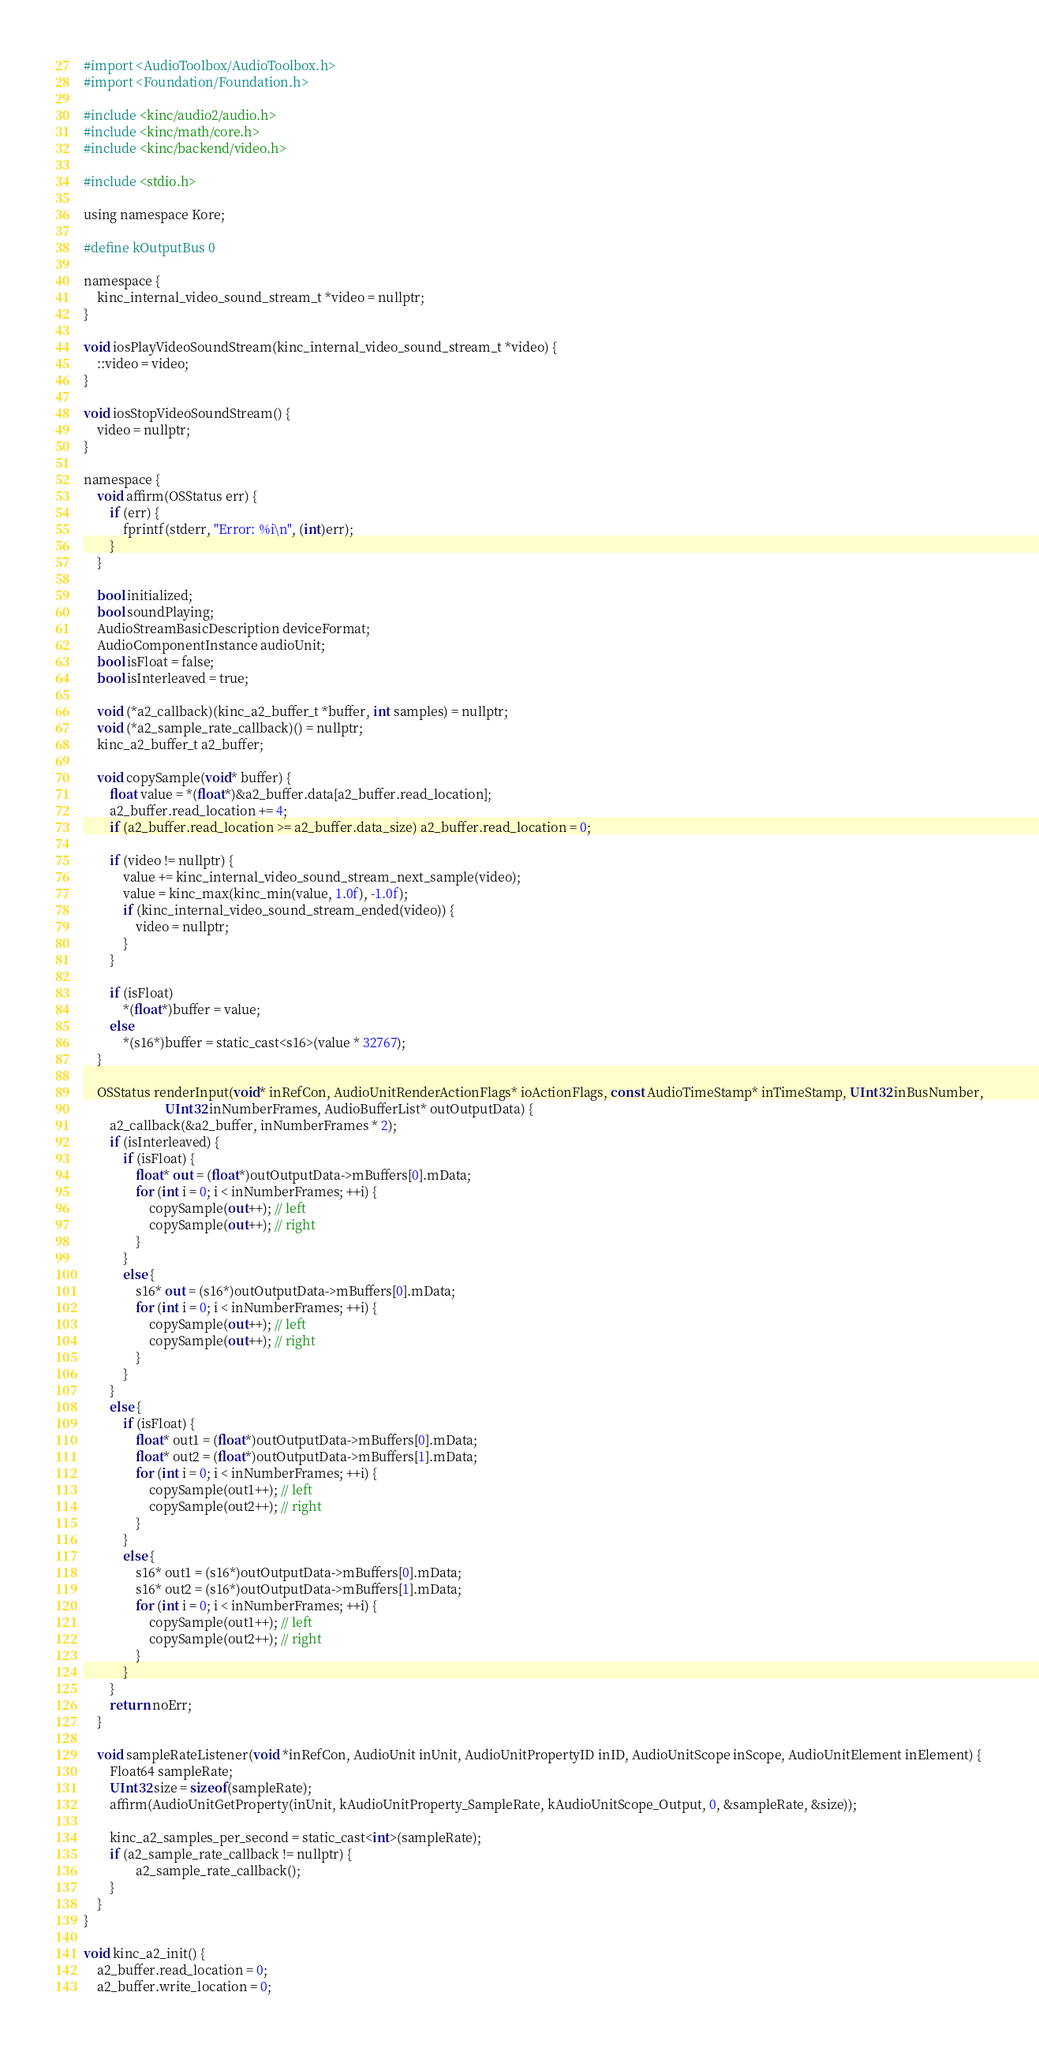Convert code to text. <code><loc_0><loc_0><loc_500><loc_500><_ObjectiveC_>#import <AudioToolbox/AudioToolbox.h>
#import <Foundation/Foundation.h>

#include <kinc/audio2/audio.h>
#include <kinc/math/core.h>
#include <kinc/backend/video.h>

#include <stdio.h>

using namespace Kore;

#define kOutputBus 0

namespace {
	kinc_internal_video_sound_stream_t *video = nullptr;
}

void iosPlayVideoSoundStream(kinc_internal_video_sound_stream_t *video) {
	::video = video;
}

void iosStopVideoSoundStream() {
	video = nullptr;
}

namespace {
	void affirm(OSStatus err) {
		if (err) {
			fprintf(stderr, "Error: %i\n", (int)err);
		}
	}

	bool initialized;
	bool soundPlaying;
	AudioStreamBasicDescription deviceFormat;
	AudioComponentInstance audioUnit;
	bool isFloat = false;
	bool isInterleaved = true;
	
	void (*a2_callback)(kinc_a2_buffer_t *buffer, int samples) = nullptr;
	void (*a2_sample_rate_callback)() = nullptr;
	kinc_a2_buffer_t a2_buffer;

	void copySample(void* buffer) {
		float value = *(float*)&a2_buffer.data[a2_buffer.read_location];
		a2_buffer.read_location += 4;
		if (a2_buffer.read_location >= a2_buffer.data_size) a2_buffer.read_location = 0;

		if (video != nullptr) {
            value += kinc_internal_video_sound_stream_next_sample(video);
			value = kinc_max(kinc_min(value, 1.0f), -1.0f);
            if (kinc_internal_video_sound_stream_ended(video)) {
                video = nullptr;
            }
        }

		if (isFloat)
			*(float*)buffer = value;
		else
			*(s16*)buffer = static_cast<s16>(value * 32767);
	}

	OSStatus renderInput(void* inRefCon, AudioUnitRenderActionFlags* ioActionFlags, const AudioTimeStamp* inTimeStamp, UInt32 inBusNumber,
	                     UInt32 inNumberFrames, AudioBufferList* outOutputData) {
		a2_callback(&a2_buffer, inNumberFrames * 2);
		if (isInterleaved) {
			if (isFloat) {
				float* out = (float*)outOutputData->mBuffers[0].mData;
				for (int i = 0; i < inNumberFrames; ++i) {
					copySample(out++); // left
					copySample(out++); // right
				}
			}
			else {
				s16* out = (s16*)outOutputData->mBuffers[0].mData;
				for (int i = 0; i < inNumberFrames; ++i) {
					copySample(out++); // left
					copySample(out++); // right
				}
			}
		}
		else {
			if (isFloat) {
				float* out1 = (float*)outOutputData->mBuffers[0].mData;
				float* out2 = (float*)outOutputData->mBuffers[1].mData;
				for (int i = 0; i < inNumberFrames; ++i) {
					copySample(out1++); // left
					copySample(out2++); // right
				}
			}
			else {
				s16* out1 = (s16*)outOutputData->mBuffers[0].mData;
				s16* out2 = (s16*)outOutputData->mBuffers[1].mData;
				for (int i = 0; i < inNumberFrames; ++i) {
					copySample(out1++); // left
					copySample(out2++); // right
				}
			}
		}
		return noErr;
	}

	void sampleRateListener(void *inRefCon, AudioUnit inUnit, AudioUnitPropertyID inID, AudioUnitScope inScope, AudioUnitElement inElement) {
		Float64 sampleRate;
		UInt32 size = sizeof(sampleRate);
		affirm(AudioUnitGetProperty(inUnit, kAudioUnitProperty_SampleRate, kAudioUnitScope_Output, 0, &sampleRate, &size));

		kinc_a2_samples_per_second = static_cast<int>(sampleRate);
		if (a2_sample_rate_callback != nullptr) {
				a2_sample_rate_callback();
		}
	}
}

void kinc_a2_init() {
	a2_buffer.read_location = 0;
	a2_buffer.write_location = 0;</code> 